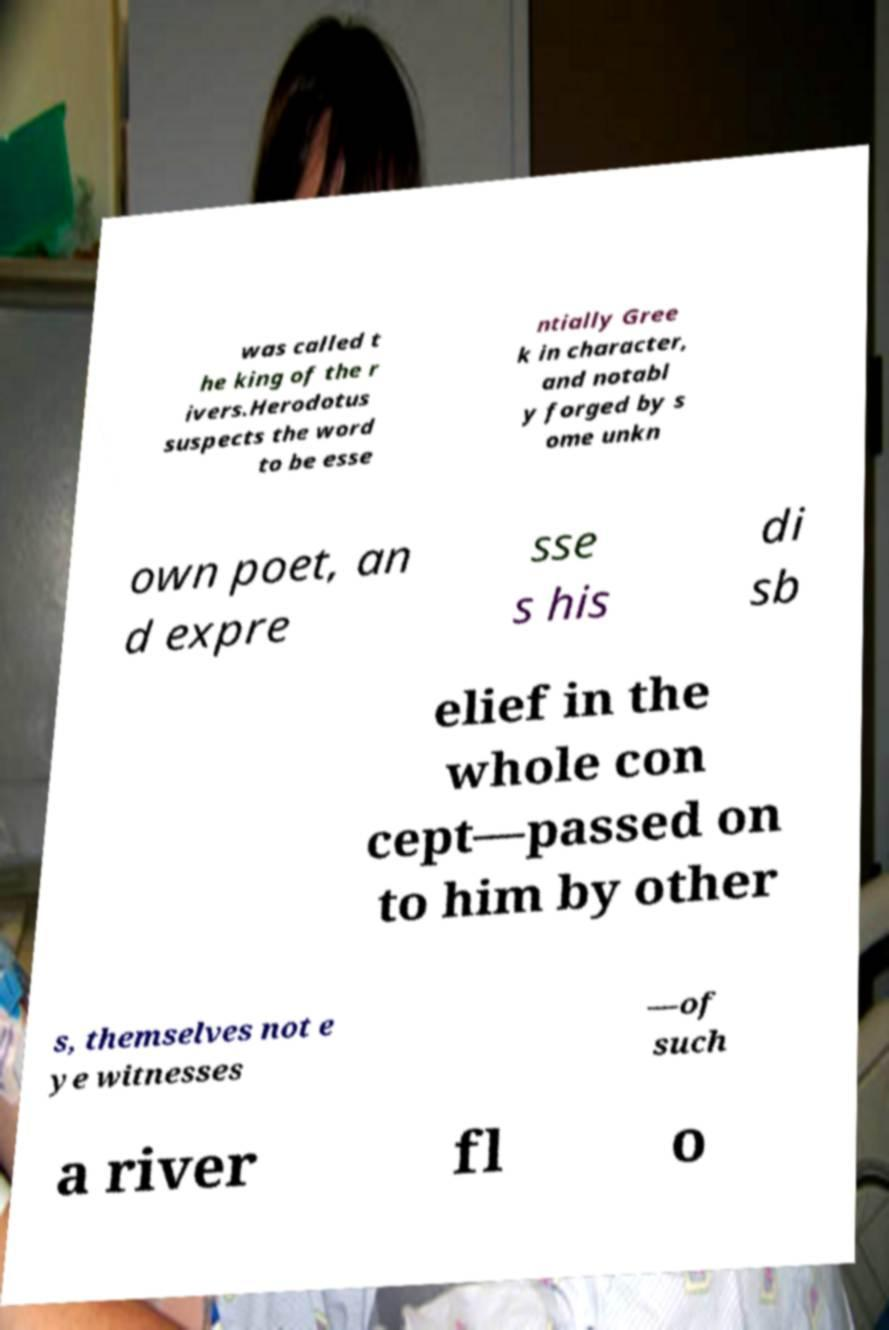Can you accurately transcribe the text from the provided image for me? was called t he king of the r ivers.Herodotus suspects the word to be esse ntially Gree k in character, and notabl y forged by s ome unkn own poet, an d expre sse s his di sb elief in the whole con cept—passed on to him by other s, themselves not e ye witnesses —of such a river fl o 